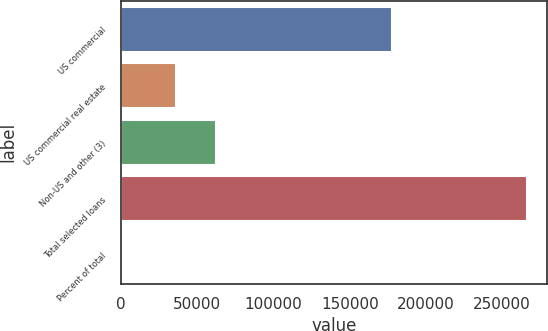Convert chart to OTSL. <chart><loc_0><loc_0><loc_500><loc_500><bar_chart><fcel>US commercial<fcel>US commercial real estate<fcel>Non-US and other (3)<fcel>Total selected loans<fcel>Percent of total<nl><fcel>177459<fcel>35741<fcel>62364.6<fcel>266294<fcel>58<nl></chart> 